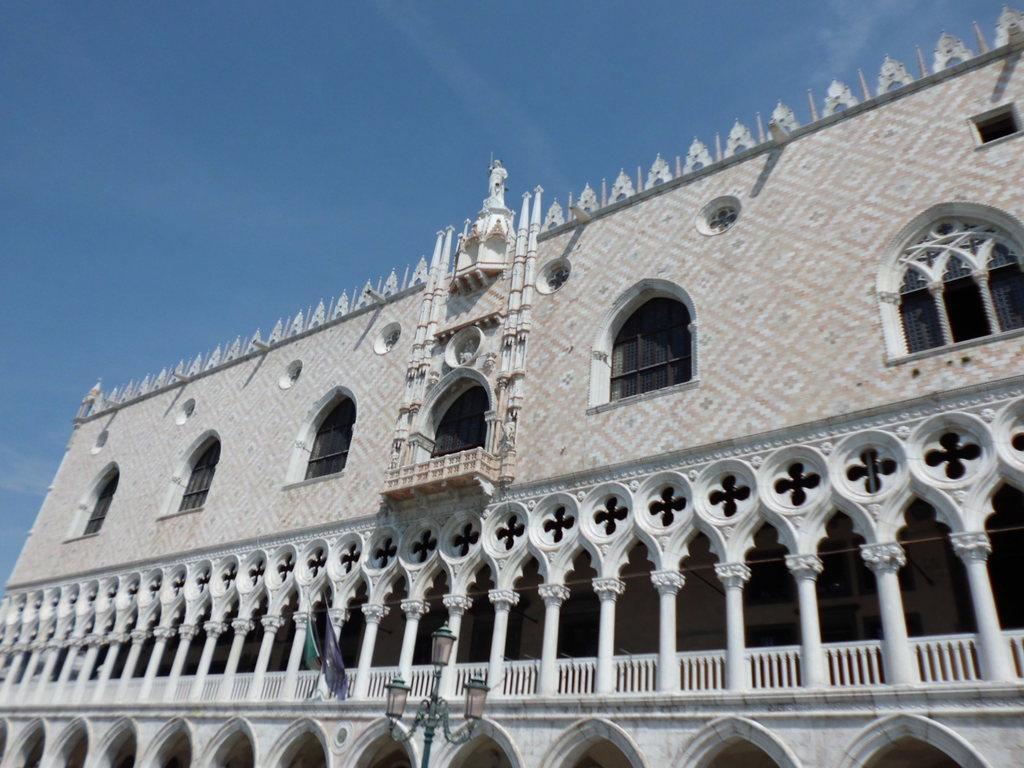How would you summarize this image in a sentence or two? This image is taken outdoors. At the top of the image there is the sky with clouds. In the middle of the image there is a building with walls, windows, pillars, railings and there are a few carvings on the wall. 